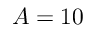Convert formula to latex. <formula><loc_0><loc_0><loc_500><loc_500>A = 1 0</formula> 